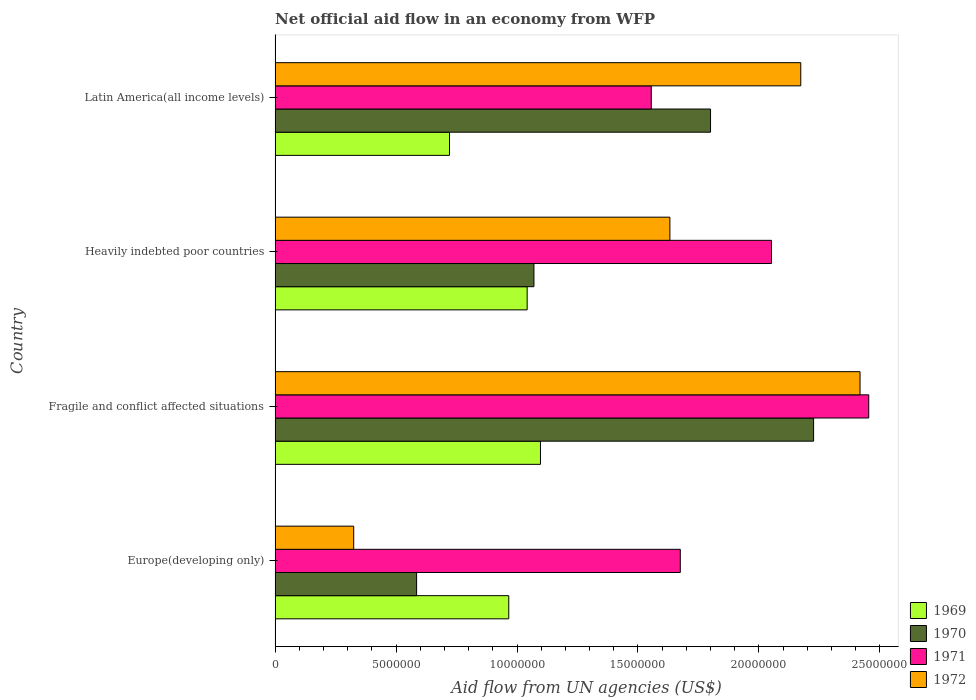How many different coloured bars are there?
Provide a succinct answer. 4. How many groups of bars are there?
Keep it short and to the point. 4. Are the number of bars per tick equal to the number of legend labels?
Ensure brevity in your answer.  Yes. How many bars are there on the 1st tick from the bottom?
Your answer should be very brief. 4. What is the label of the 2nd group of bars from the top?
Keep it short and to the point. Heavily indebted poor countries. What is the net official aid flow in 1971 in Fragile and conflict affected situations?
Your answer should be compact. 2.45e+07. Across all countries, what is the maximum net official aid flow in 1969?
Your response must be concise. 1.10e+07. Across all countries, what is the minimum net official aid flow in 1969?
Your response must be concise. 7.21e+06. In which country was the net official aid flow in 1972 maximum?
Offer a very short reply. Fragile and conflict affected situations. In which country was the net official aid flow in 1969 minimum?
Offer a terse response. Latin America(all income levels). What is the total net official aid flow in 1970 in the graph?
Your answer should be compact. 5.68e+07. What is the difference between the net official aid flow in 1969 in Fragile and conflict affected situations and that in Latin America(all income levels)?
Provide a short and direct response. 3.76e+06. What is the difference between the net official aid flow in 1971 in Heavily indebted poor countries and the net official aid flow in 1969 in Fragile and conflict affected situations?
Offer a terse response. 9.55e+06. What is the average net official aid flow in 1971 per country?
Your response must be concise. 1.93e+07. What is the difference between the net official aid flow in 1972 and net official aid flow in 1971 in Latin America(all income levels)?
Make the answer very short. 6.18e+06. In how many countries, is the net official aid flow in 1972 greater than 24000000 US$?
Ensure brevity in your answer.  1. What is the ratio of the net official aid flow in 1970 in Europe(developing only) to that in Latin America(all income levels)?
Provide a short and direct response. 0.33. Is the net official aid flow in 1972 in Fragile and conflict affected situations less than that in Latin America(all income levels)?
Give a very brief answer. No. What is the difference between the highest and the second highest net official aid flow in 1970?
Give a very brief answer. 4.26e+06. What is the difference between the highest and the lowest net official aid flow in 1969?
Give a very brief answer. 3.76e+06. In how many countries, is the net official aid flow in 1969 greater than the average net official aid flow in 1969 taken over all countries?
Provide a succinct answer. 3. Is the sum of the net official aid flow in 1971 in Europe(developing only) and Heavily indebted poor countries greater than the maximum net official aid flow in 1970 across all countries?
Your response must be concise. Yes. What does the 3rd bar from the top in Heavily indebted poor countries represents?
Provide a short and direct response. 1970. What does the 2nd bar from the bottom in Heavily indebted poor countries represents?
Keep it short and to the point. 1970. Is it the case that in every country, the sum of the net official aid flow in 1972 and net official aid flow in 1970 is greater than the net official aid flow in 1971?
Your response must be concise. No. Are all the bars in the graph horizontal?
Offer a terse response. Yes. Does the graph contain grids?
Offer a very short reply. No. How many legend labels are there?
Provide a short and direct response. 4. What is the title of the graph?
Keep it short and to the point. Net official aid flow in an economy from WFP. What is the label or title of the X-axis?
Your answer should be very brief. Aid flow from UN agencies (US$). What is the Aid flow from UN agencies (US$) of 1969 in Europe(developing only)?
Offer a terse response. 9.66e+06. What is the Aid flow from UN agencies (US$) in 1970 in Europe(developing only)?
Make the answer very short. 5.85e+06. What is the Aid flow from UN agencies (US$) of 1971 in Europe(developing only)?
Your response must be concise. 1.68e+07. What is the Aid flow from UN agencies (US$) in 1972 in Europe(developing only)?
Offer a terse response. 3.25e+06. What is the Aid flow from UN agencies (US$) in 1969 in Fragile and conflict affected situations?
Offer a very short reply. 1.10e+07. What is the Aid flow from UN agencies (US$) in 1970 in Fragile and conflict affected situations?
Ensure brevity in your answer.  2.23e+07. What is the Aid flow from UN agencies (US$) in 1971 in Fragile and conflict affected situations?
Give a very brief answer. 2.45e+07. What is the Aid flow from UN agencies (US$) of 1972 in Fragile and conflict affected situations?
Offer a very short reply. 2.42e+07. What is the Aid flow from UN agencies (US$) in 1969 in Heavily indebted poor countries?
Provide a short and direct response. 1.04e+07. What is the Aid flow from UN agencies (US$) of 1970 in Heavily indebted poor countries?
Provide a succinct answer. 1.07e+07. What is the Aid flow from UN agencies (US$) of 1971 in Heavily indebted poor countries?
Offer a very short reply. 2.05e+07. What is the Aid flow from UN agencies (US$) in 1972 in Heavily indebted poor countries?
Offer a very short reply. 1.63e+07. What is the Aid flow from UN agencies (US$) of 1969 in Latin America(all income levels)?
Give a very brief answer. 7.21e+06. What is the Aid flow from UN agencies (US$) of 1970 in Latin America(all income levels)?
Give a very brief answer. 1.80e+07. What is the Aid flow from UN agencies (US$) of 1971 in Latin America(all income levels)?
Offer a terse response. 1.56e+07. What is the Aid flow from UN agencies (US$) of 1972 in Latin America(all income levels)?
Give a very brief answer. 2.17e+07. Across all countries, what is the maximum Aid flow from UN agencies (US$) of 1969?
Make the answer very short. 1.10e+07. Across all countries, what is the maximum Aid flow from UN agencies (US$) in 1970?
Offer a terse response. 2.23e+07. Across all countries, what is the maximum Aid flow from UN agencies (US$) in 1971?
Your answer should be compact. 2.45e+07. Across all countries, what is the maximum Aid flow from UN agencies (US$) of 1972?
Offer a very short reply. 2.42e+07. Across all countries, what is the minimum Aid flow from UN agencies (US$) in 1969?
Provide a short and direct response. 7.21e+06. Across all countries, what is the minimum Aid flow from UN agencies (US$) of 1970?
Offer a very short reply. 5.85e+06. Across all countries, what is the minimum Aid flow from UN agencies (US$) in 1971?
Offer a very short reply. 1.56e+07. Across all countries, what is the minimum Aid flow from UN agencies (US$) in 1972?
Make the answer very short. 3.25e+06. What is the total Aid flow from UN agencies (US$) in 1969 in the graph?
Make the answer very short. 3.83e+07. What is the total Aid flow from UN agencies (US$) in 1970 in the graph?
Your response must be concise. 5.68e+07. What is the total Aid flow from UN agencies (US$) of 1971 in the graph?
Your answer should be very brief. 7.74e+07. What is the total Aid flow from UN agencies (US$) of 1972 in the graph?
Make the answer very short. 6.55e+07. What is the difference between the Aid flow from UN agencies (US$) in 1969 in Europe(developing only) and that in Fragile and conflict affected situations?
Provide a succinct answer. -1.31e+06. What is the difference between the Aid flow from UN agencies (US$) in 1970 in Europe(developing only) and that in Fragile and conflict affected situations?
Your answer should be very brief. -1.64e+07. What is the difference between the Aid flow from UN agencies (US$) in 1971 in Europe(developing only) and that in Fragile and conflict affected situations?
Offer a terse response. -7.79e+06. What is the difference between the Aid flow from UN agencies (US$) of 1972 in Europe(developing only) and that in Fragile and conflict affected situations?
Your answer should be compact. -2.09e+07. What is the difference between the Aid flow from UN agencies (US$) in 1969 in Europe(developing only) and that in Heavily indebted poor countries?
Keep it short and to the point. -7.60e+05. What is the difference between the Aid flow from UN agencies (US$) in 1970 in Europe(developing only) and that in Heavily indebted poor countries?
Provide a short and direct response. -4.85e+06. What is the difference between the Aid flow from UN agencies (US$) in 1971 in Europe(developing only) and that in Heavily indebted poor countries?
Offer a very short reply. -3.77e+06. What is the difference between the Aid flow from UN agencies (US$) in 1972 in Europe(developing only) and that in Heavily indebted poor countries?
Ensure brevity in your answer.  -1.31e+07. What is the difference between the Aid flow from UN agencies (US$) in 1969 in Europe(developing only) and that in Latin America(all income levels)?
Provide a succinct answer. 2.45e+06. What is the difference between the Aid flow from UN agencies (US$) of 1970 in Europe(developing only) and that in Latin America(all income levels)?
Your answer should be compact. -1.22e+07. What is the difference between the Aid flow from UN agencies (US$) of 1971 in Europe(developing only) and that in Latin America(all income levels)?
Keep it short and to the point. 1.20e+06. What is the difference between the Aid flow from UN agencies (US$) in 1972 in Europe(developing only) and that in Latin America(all income levels)?
Your answer should be very brief. -1.85e+07. What is the difference between the Aid flow from UN agencies (US$) of 1970 in Fragile and conflict affected situations and that in Heavily indebted poor countries?
Offer a very short reply. 1.16e+07. What is the difference between the Aid flow from UN agencies (US$) in 1971 in Fragile and conflict affected situations and that in Heavily indebted poor countries?
Offer a terse response. 4.02e+06. What is the difference between the Aid flow from UN agencies (US$) of 1972 in Fragile and conflict affected situations and that in Heavily indebted poor countries?
Provide a short and direct response. 7.86e+06. What is the difference between the Aid flow from UN agencies (US$) in 1969 in Fragile and conflict affected situations and that in Latin America(all income levels)?
Offer a very short reply. 3.76e+06. What is the difference between the Aid flow from UN agencies (US$) in 1970 in Fragile and conflict affected situations and that in Latin America(all income levels)?
Make the answer very short. 4.26e+06. What is the difference between the Aid flow from UN agencies (US$) in 1971 in Fragile and conflict affected situations and that in Latin America(all income levels)?
Offer a very short reply. 8.99e+06. What is the difference between the Aid flow from UN agencies (US$) in 1972 in Fragile and conflict affected situations and that in Latin America(all income levels)?
Provide a short and direct response. 2.45e+06. What is the difference between the Aid flow from UN agencies (US$) in 1969 in Heavily indebted poor countries and that in Latin America(all income levels)?
Ensure brevity in your answer.  3.21e+06. What is the difference between the Aid flow from UN agencies (US$) in 1970 in Heavily indebted poor countries and that in Latin America(all income levels)?
Provide a succinct answer. -7.30e+06. What is the difference between the Aid flow from UN agencies (US$) in 1971 in Heavily indebted poor countries and that in Latin America(all income levels)?
Offer a terse response. 4.97e+06. What is the difference between the Aid flow from UN agencies (US$) of 1972 in Heavily indebted poor countries and that in Latin America(all income levels)?
Ensure brevity in your answer.  -5.41e+06. What is the difference between the Aid flow from UN agencies (US$) in 1969 in Europe(developing only) and the Aid flow from UN agencies (US$) in 1970 in Fragile and conflict affected situations?
Provide a succinct answer. -1.26e+07. What is the difference between the Aid flow from UN agencies (US$) in 1969 in Europe(developing only) and the Aid flow from UN agencies (US$) in 1971 in Fragile and conflict affected situations?
Make the answer very short. -1.49e+07. What is the difference between the Aid flow from UN agencies (US$) in 1969 in Europe(developing only) and the Aid flow from UN agencies (US$) in 1972 in Fragile and conflict affected situations?
Your response must be concise. -1.45e+07. What is the difference between the Aid flow from UN agencies (US$) of 1970 in Europe(developing only) and the Aid flow from UN agencies (US$) of 1971 in Fragile and conflict affected situations?
Give a very brief answer. -1.87e+07. What is the difference between the Aid flow from UN agencies (US$) of 1970 in Europe(developing only) and the Aid flow from UN agencies (US$) of 1972 in Fragile and conflict affected situations?
Make the answer very short. -1.83e+07. What is the difference between the Aid flow from UN agencies (US$) in 1971 in Europe(developing only) and the Aid flow from UN agencies (US$) in 1972 in Fragile and conflict affected situations?
Make the answer very short. -7.43e+06. What is the difference between the Aid flow from UN agencies (US$) of 1969 in Europe(developing only) and the Aid flow from UN agencies (US$) of 1970 in Heavily indebted poor countries?
Provide a short and direct response. -1.04e+06. What is the difference between the Aid flow from UN agencies (US$) in 1969 in Europe(developing only) and the Aid flow from UN agencies (US$) in 1971 in Heavily indebted poor countries?
Offer a terse response. -1.09e+07. What is the difference between the Aid flow from UN agencies (US$) of 1969 in Europe(developing only) and the Aid flow from UN agencies (US$) of 1972 in Heavily indebted poor countries?
Keep it short and to the point. -6.66e+06. What is the difference between the Aid flow from UN agencies (US$) of 1970 in Europe(developing only) and the Aid flow from UN agencies (US$) of 1971 in Heavily indebted poor countries?
Offer a terse response. -1.47e+07. What is the difference between the Aid flow from UN agencies (US$) in 1970 in Europe(developing only) and the Aid flow from UN agencies (US$) in 1972 in Heavily indebted poor countries?
Make the answer very short. -1.05e+07. What is the difference between the Aid flow from UN agencies (US$) of 1971 in Europe(developing only) and the Aid flow from UN agencies (US$) of 1972 in Heavily indebted poor countries?
Ensure brevity in your answer.  4.30e+05. What is the difference between the Aid flow from UN agencies (US$) of 1969 in Europe(developing only) and the Aid flow from UN agencies (US$) of 1970 in Latin America(all income levels)?
Offer a terse response. -8.34e+06. What is the difference between the Aid flow from UN agencies (US$) of 1969 in Europe(developing only) and the Aid flow from UN agencies (US$) of 1971 in Latin America(all income levels)?
Give a very brief answer. -5.89e+06. What is the difference between the Aid flow from UN agencies (US$) in 1969 in Europe(developing only) and the Aid flow from UN agencies (US$) in 1972 in Latin America(all income levels)?
Give a very brief answer. -1.21e+07. What is the difference between the Aid flow from UN agencies (US$) in 1970 in Europe(developing only) and the Aid flow from UN agencies (US$) in 1971 in Latin America(all income levels)?
Give a very brief answer. -9.70e+06. What is the difference between the Aid flow from UN agencies (US$) in 1970 in Europe(developing only) and the Aid flow from UN agencies (US$) in 1972 in Latin America(all income levels)?
Ensure brevity in your answer.  -1.59e+07. What is the difference between the Aid flow from UN agencies (US$) of 1971 in Europe(developing only) and the Aid flow from UN agencies (US$) of 1972 in Latin America(all income levels)?
Provide a short and direct response. -4.98e+06. What is the difference between the Aid flow from UN agencies (US$) of 1969 in Fragile and conflict affected situations and the Aid flow from UN agencies (US$) of 1970 in Heavily indebted poor countries?
Provide a succinct answer. 2.70e+05. What is the difference between the Aid flow from UN agencies (US$) of 1969 in Fragile and conflict affected situations and the Aid flow from UN agencies (US$) of 1971 in Heavily indebted poor countries?
Give a very brief answer. -9.55e+06. What is the difference between the Aid flow from UN agencies (US$) in 1969 in Fragile and conflict affected situations and the Aid flow from UN agencies (US$) in 1972 in Heavily indebted poor countries?
Offer a very short reply. -5.35e+06. What is the difference between the Aid flow from UN agencies (US$) in 1970 in Fragile and conflict affected situations and the Aid flow from UN agencies (US$) in 1971 in Heavily indebted poor countries?
Provide a succinct answer. 1.74e+06. What is the difference between the Aid flow from UN agencies (US$) of 1970 in Fragile and conflict affected situations and the Aid flow from UN agencies (US$) of 1972 in Heavily indebted poor countries?
Make the answer very short. 5.94e+06. What is the difference between the Aid flow from UN agencies (US$) of 1971 in Fragile and conflict affected situations and the Aid flow from UN agencies (US$) of 1972 in Heavily indebted poor countries?
Offer a very short reply. 8.22e+06. What is the difference between the Aid flow from UN agencies (US$) in 1969 in Fragile and conflict affected situations and the Aid flow from UN agencies (US$) in 1970 in Latin America(all income levels)?
Keep it short and to the point. -7.03e+06. What is the difference between the Aid flow from UN agencies (US$) in 1969 in Fragile and conflict affected situations and the Aid flow from UN agencies (US$) in 1971 in Latin America(all income levels)?
Provide a short and direct response. -4.58e+06. What is the difference between the Aid flow from UN agencies (US$) in 1969 in Fragile and conflict affected situations and the Aid flow from UN agencies (US$) in 1972 in Latin America(all income levels)?
Your answer should be compact. -1.08e+07. What is the difference between the Aid flow from UN agencies (US$) in 1970 in Fragile and conflict affected situations and the Aid flow from UN agencies (US$) in 1971 in Latin America(all income levels)?
Give a very brief answer. 6.71e+06. What is the difference between the Aid flow from UN agencies (US$) in 1970 in Fragile and conflict affected situations and the Aid flow from UN agencies (US$) in 1972 in Latin America(all income levels)?
Your response must be concise. 5.30e+05. What is the difference between the Aid flow from UN agencies (US$) of 1971 in Fragile and conflict affected situations and the Aid flow from UN agencies (US$) of 1972 in Latin America(all income levels)?
Offer a terse response. 2.81e+06. What is the difference between the Aid flow from UN agencies (US$) in 1969 in Heavily indebted poor countries and the Aid flow from UN agencies (US$) in 1970 in Latin America(all income levels)?
Ensure brevity in your answer.  -7.58e+06. What is the difference between the Aid flow from UN agencies (US$) in 1969 in Heavily indebted poor countries and the Aid flow from UN agencies (US$) in 1971 in Latin America(all income levels)?
Give a very brief answer. -5.13e+06. What is the difference between the Aid flow from UN agencies (US$) in 1969 in Heavily indebted poor countries and the Aid flow from UN agencies (US$) in 1972 in Latin America(all income levels)?
Provide a succinct answer. -1.13e+07. What is the difference between the Aid flow from UN agencies (US$) in 1970 in Heavily indebted poor countries and the Aid flow from UN agencies (US$) in 1971 in Latin America(all income levels)?
Offer a very short reply. -4.85e+06. What is the difference between the Aid flow from UN agencies (US$) of 1970 in Heavily indebted poor countries and the Aid flow from UN agencies (US$) of 1972 in Latin America(all income levels)?
Make the answer very short. -1.10e+07. What is the difference between the Aid flow from UN agencies (US$) in 1971 in Heavily indebted poor countries and the Aid flow from UN agencies (US$) in 1972 in Latin America(all income levels)?
Provide a succinct answer. -1.21e+06. What is the average Aid flow from UN agencies (US$) in 1969 per country?
Give a very brief answer. 9.56e+06. What is the average Aid flow from UN agencies (US$) in 1970 per country?
Make the answer very short. 1.42e+07. What is the average Aid flow from UN agencies (US$) of 1971 per country?
Offer a terse response. 1.93e+07. What is the average Aid flow from UN agencies (US$) in 1972 per country?
Your response must be concise. 1.64e+07. What is the difference between the Aid flow from UN agencies (US$) of 1969 and Aid flow from UN agencies (US$) of 1970 in Europe(developing only)?
Offer a very short reply. 3.81e+06. What is the difference between the Aid flow from UN agencies (US$) of 1969 and Aid flow from UN agencies (US$) of 1971 in Europe(developing only)?
Ensure brevity in your answer.  -7.09e+06. What is the difference between the Aid flow from UN agencies (US$) in 1969 and Aid flow from UN agencies (US$) in 1972 in Europe(developing only)?
Keep it short and to the point. 6.41e+06. What is the difference between the Aid flow from UN agencies (US$) in 1970 and Aid flow from UN agencies (US$) in 1971 in Europe(developing only)?
Offer a very short reply. -1.09e+07. What is the difference between the Aid flow from UN agencies (US$) in 1970 and Aid flow from UN agencies (US$) in 1972 in Europe(developing only)?
Your response must be concise. 2.60e+06. What is the difference between the Aid flow from UN agencies (US$) in 1971 and Aid flow from UN agencies (US$) in 1972 in Europe(developing only)?
Offer a terse response. 1.35e+07. What is the difference between the Aid flow from UN agencies (US$) of 1969 and Aid flow from UN agencies (US$) of 1970 in Fragile and conflict affected situations?
Your response must be concise. -1.13e+07. What is the difference between the Aid flow from UN agencies (US$) in 1969 and Aid flow from UN agencies (US$) in 1971 in Fragile and conflict affected situations?
Make the answer very short. -1.36e+07. What is the difference between the Aid flow from UN agencies (US$) in 1969 and Aid flow from UN agencies (US$) in 1972 in Fragile and conflict affected situations?
Provide a succinct answer. -1.32e+07. What is the difference between the Aid flow from UN agencies (US$) in 1970 and Aid flow from UN agencies (US$) in 1971 in Fragile and conflict affected situations?
Ensure brevity in your answer.  -2.28e+06. What is the difference between the Aid flow from UN agencies (US$) in 1970 and Aid flow from UN agencies (US$) in 1972 in Fragile and conflict affected situations?
Provide a short and direct response. -1.92e+06. What is the difference between the Aid flow from UN agencies (US$) of 1971 and Aid flow from UN agencies (US$) of 1972 in Fragile and conflict affected situations?
Provide a succinct answer. 3.60e+05. What is the difference between the Aid flow from UN agencies (US$) in 1969 and Aid flow from UN agencies (US$) in 1970 in Heavily indebted poor countries?
Make the answer very short. -2.80e+05. What is the difference between the Aid flow from UN agencies (US$) of 1969 and Aid flow from UN agencies (US$) of 1971 in Heavily indebted poor countries?
Provide a succinct answer. -1.01e+07. What is the difference between the Aid flow from UN agencies (US$) in 1969 and Aid flow from UN agencies (US$) in 1972 in Heavily indebted poor countries?
Your answer should be compact. -5.90e+06. What is the difference between the Aid flow from UN agencies (US$) of 1970 and Aid flow from UN agencies (US$) of 1971 in Heavily indebted poor countries?
Your answer should be compact. -9.82e+06. What is the difference between the Aid flow from UN agencies (US$) of 1970 and Aid flow from UN agencies (US$) of 1972 in Heavily indebted poor countries?
Make the answer very short. -5.62e+06. What is the difference between the Aid flow from UN agencies (US$) in 1971 and Aid flow from UN agencies (US$) in 1972 in Heavily indebted poor countries?
Your answer should be compact. 4.20e+06. What is the difference between the Aid flow from UN agencies (US$) of 1969 and Aid flow from UN agencies (US$) of 1970 in Latin America(all income levels)?
Your answer should be very brief. -1.08e+07. What is the difference between the Aid flow from UN agencies (US$) of 1969 and Aid flow from UN agencies (US$) of 1971 in Latin America(all income levels)?
Give a very brief answer. -8.34e+06. What is the difference between the Aid flow from UN agencies (US$) of 1969 and Aid flow from UN agencies (US$) of 1972 in Latin America(all income levels)?
Keep it short and to the point. -1.45e+07. What is the difference between the Aid flow from UN agencies (US$) of 1970 and Aid flow from UN agencies (US$) of 1971 in Latin America(all income levels)?
Ensure brevity in your answer.  2.45e+06. What is the difference between the Aid flow from UN agencies (US$) of 1970 and Aid flow from UN agencies (US$) of 1972 in Latin America(all income levels)?
Provide a short and direct response. -3.73e+06. What is the difference between the Aid flow from UN agencies (US$) of 1971 and Aid flow from UN agencies (US$) of 1972 in Latin America(all income levels)?
Provide a succinct answer. -6.18e+06. What is the ratio of the Aid flow from UN agencies (US$) of 1969 in Europe(developing only) to that in Fragile and conflict affected situations?
Keep it short and to the point. 0.88. What is the ratio of the Aid flow from UN agencies (US$) in 1970 in Europe(developing only) to that in Fragile and conflict affected situations?
Give a very brief answer. 0.26. What is the ratio of the Aid flow from UN agencies (US$) of 1971 in Europe(developing only) to that in Fragile and conflict affected situations?
Offer a very short reply. 0.68. What is the ratio of the Aid flow from UN agencies (US$) in 1972 in Europe(developing only) to that in Fragile and conflict affected situations?
Offer a very short reply. 0.13. What is the ratio of the Aid flow from UN agencies (US$) in 1969 in Europe(developing only) to that in Heavily indebted poor countries?
Your answer should be very brief. 0.93. What is the ratio of the Aid flow from UN agencies (US$) in 1970 in Europe(developing only) to that in Heavily indebted poor countries?
Your answer should be compact. 0.55. What is the ratio of the Aid flow from UN agencies (US$) of 1971 in Europe(developing only) to that in Heavily indebted poor countries?
Keep it short and to the point. 0.82. What is the ratio of the Aid flow from UN agencies (US$) in 1972 in Europe(developing only) to that in Heavily indebted poor countries?
Offer a terse response. 0.2. What is the ratio of the Aid flow from UN agencies (US$) of 1969 in Europe(developing only) to that in Latin America(all income levels)?
Offer a terse response. 1.34. What is the ratio of the Aid flow from UN agencies (US$) in 1970 in Europe(developing only) to that in Latin America(all income levels)?
Give a very brief answer. 0.33. What is the ratio of the Aid flow from UN agencies (US$) of 1971 in Europe(developing only) to that in Latin America(all income levels)?
Ensure brevity in your answer.  1.08. What is the ratio of the Aid flow from UN agencies (US$) in 1972 in Europe(developing only) to that in Latin America(all income levels)?
Provide a short and direct response. 0.15. What is the ratio of the Aid flow from UN agencies (US$) of 1969 in Fragile and conflict affected situations to that in Heavily indebted poor countries?
Your answer should be very brief. 1.05. What is the ratio of the Aid flow from UN agencies (US$) in 1970 in Fragile and conflict affected situations to that in Heavily indebted poor countries?
Provide a short and direct response. 2.08. What is the ratio of the Aid flow from UN agencies (US$) of 1971 in Fragile and conflict affected situations to that in Heavily indebted poor countries?
Your answer should be compact. 1.2. What is the ratio of the Aid flow from UN agencies (US$) of 1972 in Fragile and conflict affected situations to that in Heavily indebted poor countries?
Give a very brief answer. 1.48. What is the ratio of the Aid flow from UN agencies (US$) of 1969 in Fragile and conflict affected situations to that in Latin America(all income levels)?
Give a very brief answer. 1.52. What is the ratio of the Aid flow from UN agencies (US$) in 1970 in Fragile and conflict affected situations to that in Latin America(all income levels)?
Your answer should be very brief. 1.24. What is the ratio of the Aid flow from UN agencies (US$) of 1971 in Fragile and conflict affected situations to that in Latin America(all income levels)?
Offer a terse response. 1.58. What is the ratio of the Aid flow from UN agencies (US$) in 1972 in Fragile and conflict affected situations to that in Latin America(all income levels)?
Offer a very short reply. 1.11. What is the ratio of the Aid flow from UN agencies (US$) in 1969 in Heavily indebted poor countries to that in Latin America(all income levels)?
Ensure brevity in your answer.  1.45. What is the ratio of the Aid flow from UN agencies (US$) in 1970 in Heavily indebted poor countries to that in Latin America(all income levels)?
Your answer should be compact. 0.59. What is the ratio of the Aid flow from UN agencies (US$) in 1971 in Heavily indebted poor countries to that in Latin America(all income levels)?
Give a very brief answer. 1.32. What is the ratio of the Aid flow from UN agencies (US$) in 1972 in Heavily indebted poor countries to that in Latin America(all income levels)?
Provide a succinct answer. 0.75. What is the difference between the highest and the second highest Aid flow from UN agencies (US$) of 1970?
Your answer should be very brief. 4.26e+06. What is the difference between the highest and the second highest Aid flow from UN agencies (US$) in 1971?
Keep it short and to the point. 4.02e+06. What is the difference between the highest and the second highest Aid flow from UN agencies (US$) in 1972?
Your response must be concise. 2.45e+06. What is the difference between the highest and the lowest Aid flow from UN agencies (US$) of 1969?
Provide a short and direct response. 3.76e+06. What is the difference between the highest and the lowest Aid flow from UN agencies (US$) in 1970?
Ensure brevity in your answer.  1.64e+07. What is the difference between the highest and the lowest Aid flow from UN agencies (US$) of 1971?
Ensure brevity in your answer.  8.99e+06. What is the difference between the highest and the lowest Aid flow from UN agencies (US$) of 1972?
Provide a short and direct response. 2.09e+07. 